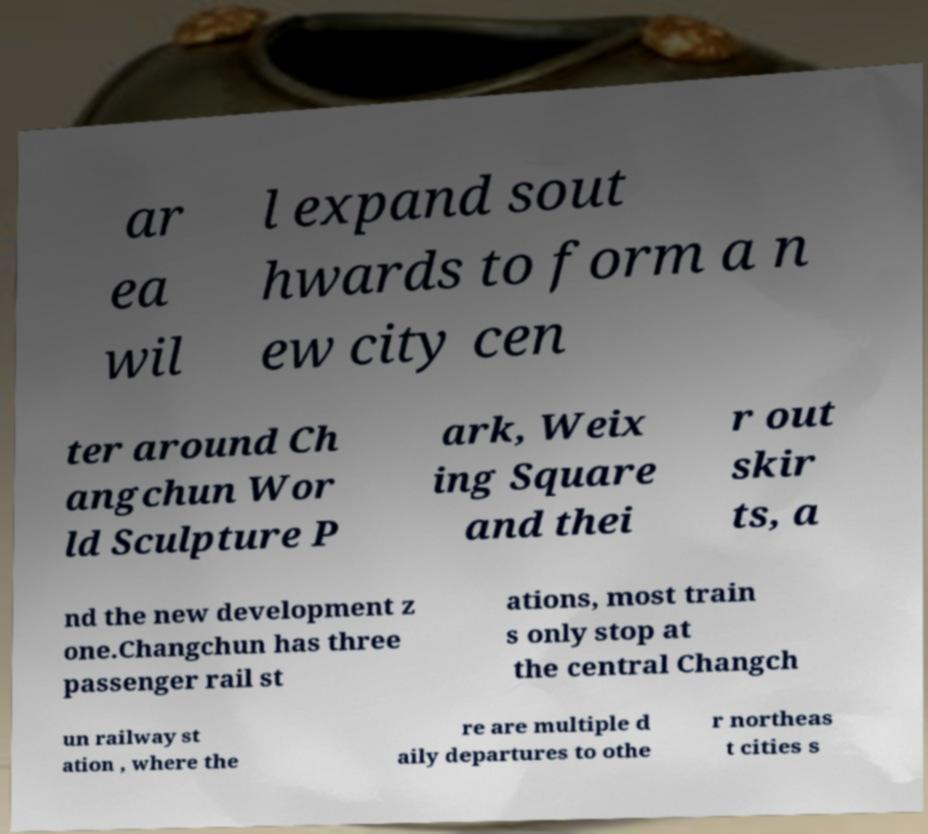There's text embedded in this image that I need extracted. Can you transcribe it verbatim? ar ea wil l expand sout hwards to form a n ew city cen ter around Ch angchun Wor ld Sculpture P ark, Weix ing Square and thei r out skir ts, a nd the new development z one.Changchun has three passenger rail st ations, most train s only stop at the central Changch un railway st ation , where the re are multiple d aily departures to othe r northeas t cities s 